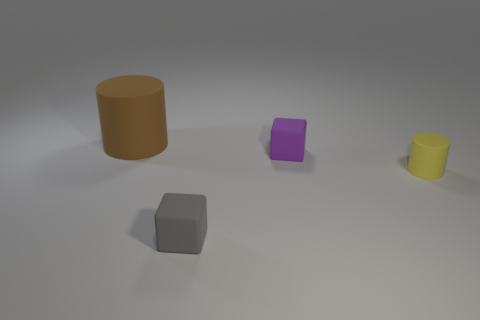Add 4 brown rubber cylinders. How many objects exist? 8 Subtract all blue cylinders. How many cyan cubes are left? 0 Subtract all gray matte things. Subtract all small cubes. How many objects are left? 1 Add 4 brown matte objects. How many brown matte objects are left? 5 Add 2 yellow matte cylinders. How many yellow matte cylinders exist? 3 Subtract 0 green cylinders. How many objects are left? 4 Subtract 1 blocks. How many blocks are left? 1 Subtract all green blocks. Subtract all blue cylinders. How many blocks are left? 2 